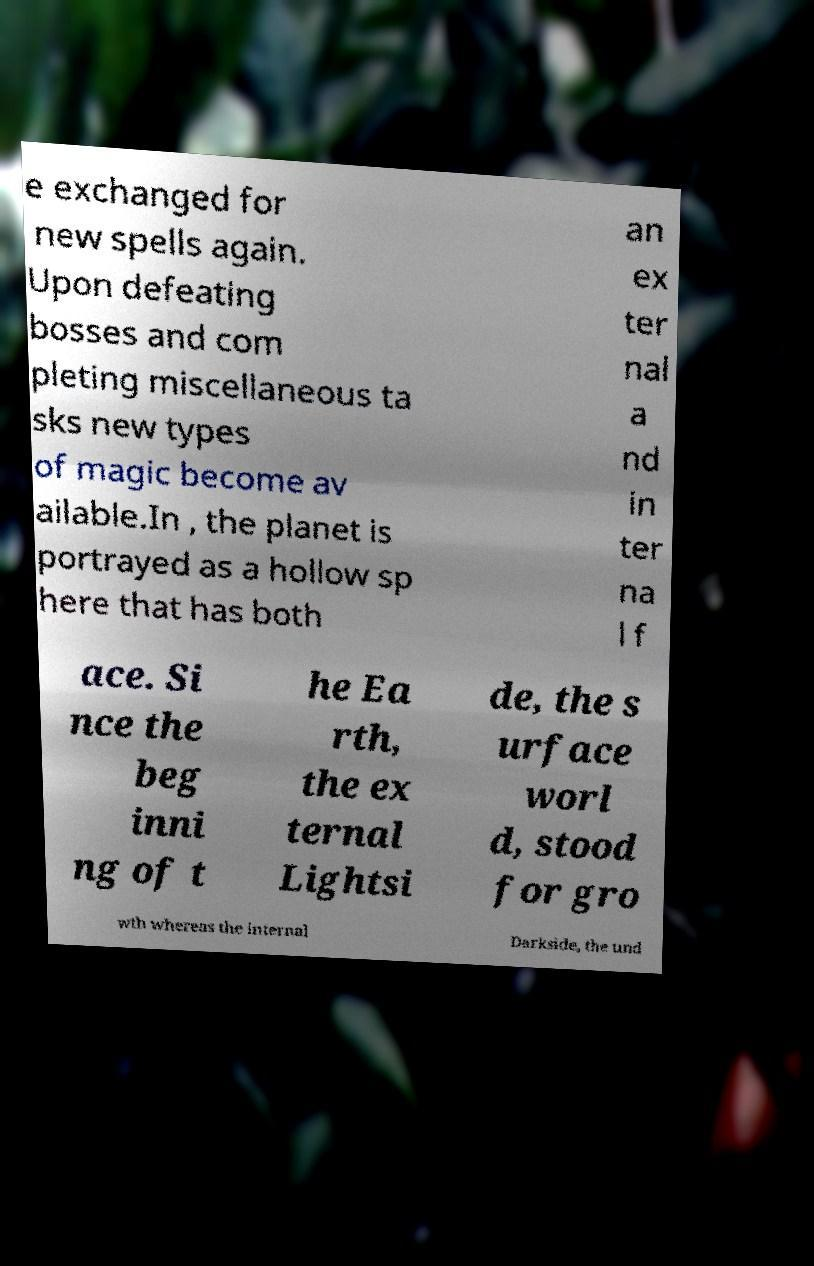Please read and relay the text visible in this image. What does it say? e exchanged for new spells again. Upon defeating bosses and com pleting miscellaneous ta sks new types of magic become av ailable.In , the planet is portrayed as a hollow sp here that has both an ex ter nal a nd in ter na l f ace. Si nce the beg inni ng of t he Ea rth, the ex ternal Lightsi de, the s urface worl d, stood for gro wth whereas the internal Darkside, the und 